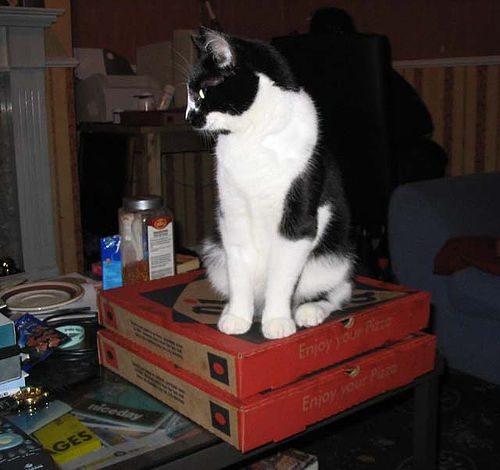Describe the objects in this image and their specific colors. I can see cat in black, lightgray, darkgray, and gray tones, chair in black and maroon tones, pizza in black, maroon, brown, and gray tones, and remote in black, gray, purple, and navy tones in this image. 